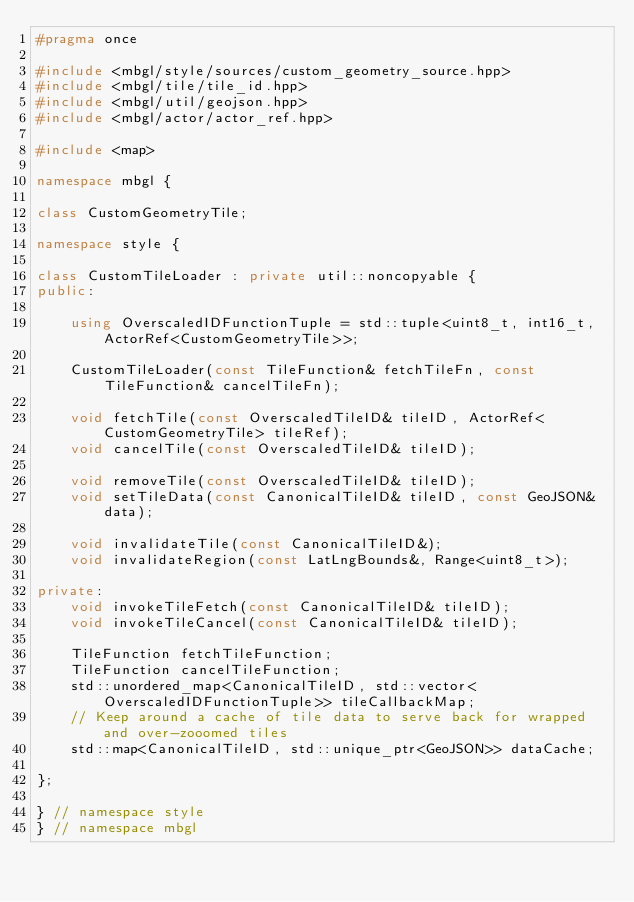Convert code to text. <code><loc_0><loc_0><loc_500><loc_500><_C++_>#pragma once

#include <mbgl/style/sources/custom_geometry_source.hpp>
#include <mbgl/tile/tile_id.hpp>
#include <mbgl/util/geojson.hpp>
#include <mbgl/actor/actor_ref.hpp>

#include <map>

namespace mbgl {

class CustomGeometryTile;

namespace style {

class CustomTileLoader : private util::noncopyable {
public:

    using OverscaledIDFunctionTuple = std::tuple<uint8_t, int16_t, ActorRef<CustomGeometryTile>>;

    CustomTileLoader(const TileFunction& fetchTileFn, const TileFunction& cancelTileFn);

    void fetchTile(const OverscaledTileID& tileID, ActorRef<CustomGeometryTile> tileRef);
    void cancelTile(const OverscaledTileID& tileID);

    void removeTile(const OverscaledTileID& tileID);
    void setTileData(const CanonicalTileID& tileID, const GeoJSON& data);

    void invalidateTile(const CanonicalTileID&);
    void invalidateRegion(const LatLngBounds&, Range<uint8_t>);

private:
    void invokeTileFetch(const CanonicalTileID& tileID);
    void invokeTileCancel(const CanonicalTileID& tileID);

    TileFunction fetchTileFunction;
    TileFunction cancelTileFunction;
    std::unordered_map<CanonicalTileID, std::vector<OverscaledIDFunctionTuple>> tileCallbackMap;
    // Keep around a cache of tile data to serve back for wrapped and over-zooomed tiles
    std::map<CanonicalTileID, std::unique_ptr<GeoJSON>> dataCache;

};

} // namespace style
} // namespace mbgl
</code> 